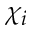<formula> <loc_0><loc_0><loc_500><loc_500>\chi _ { i }</formula> 